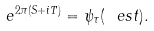Convert formula to latex. <formula><loc_0><loc_0><loc_500><loc_500>e ^ { 2 \pi ( S + i T ) } = \psi _ { \tau } ( \ e s t ) .</formula> 